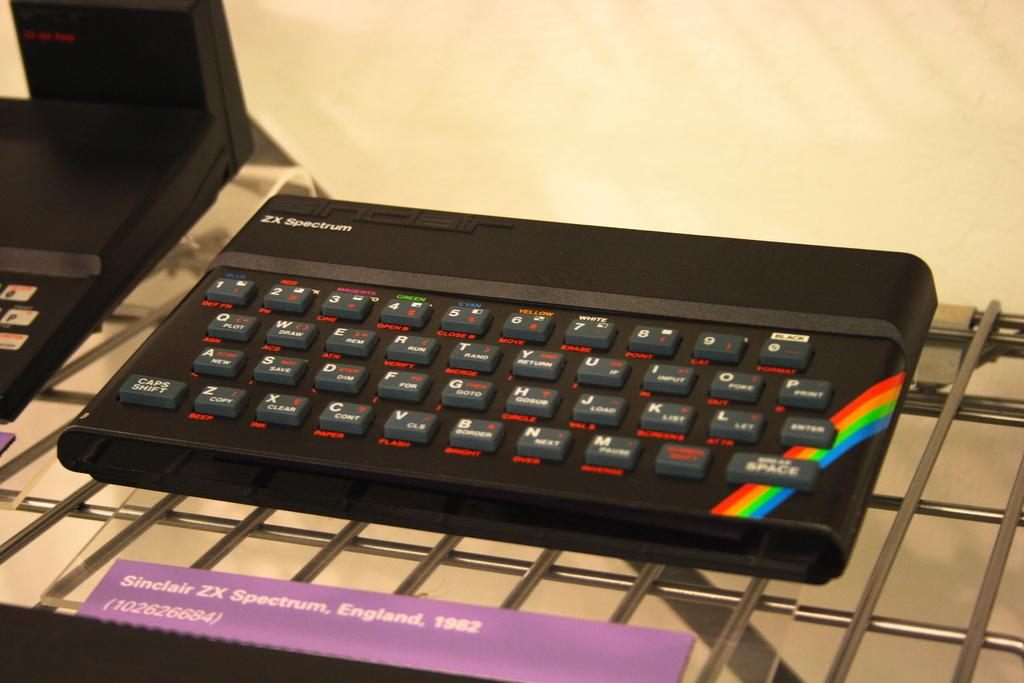<image>
Summarize the visual content of the image. The keyboard displayed is labeled as Sinclair ZX Spectrum, England, 1982. 